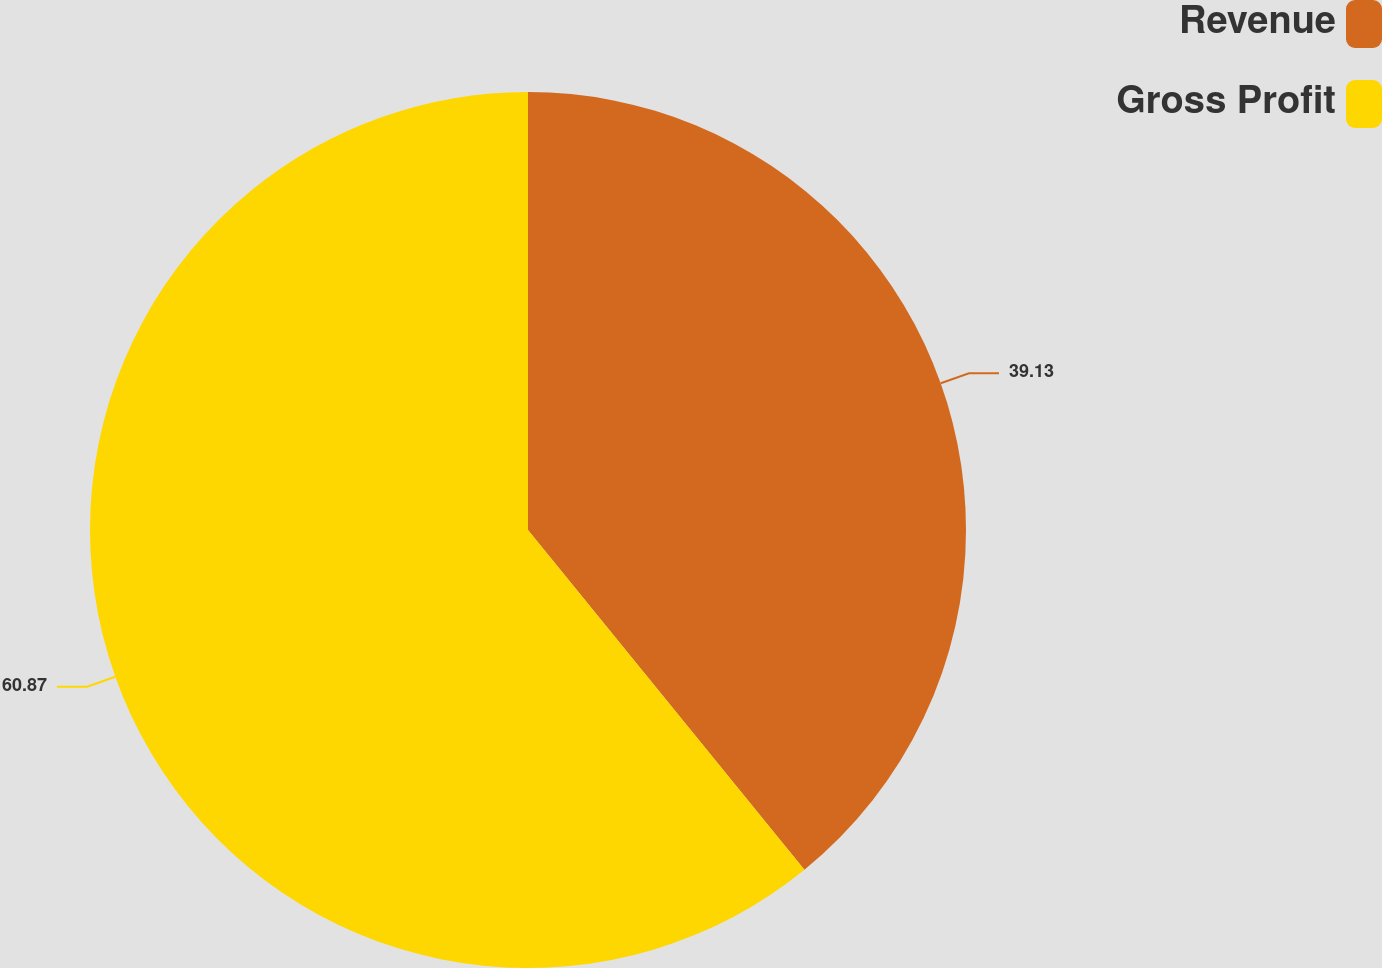Convert chart. <chart><loc_0><loc_0><loc_500><loc_500><pie_chart><fcel>Revenue<fcel>Gross Profit<nl><fcel>39.13%<fcel>60.87%<nl></chart> 